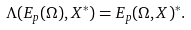<formula> <loc_0><loc_0><loc_500><loc_500>\Lambda ( E _ { p } ( \Omega ) , X ^ { \ast } ) = E _ { p } ( \Omega , X ) ^ { \ast } .</formula> 